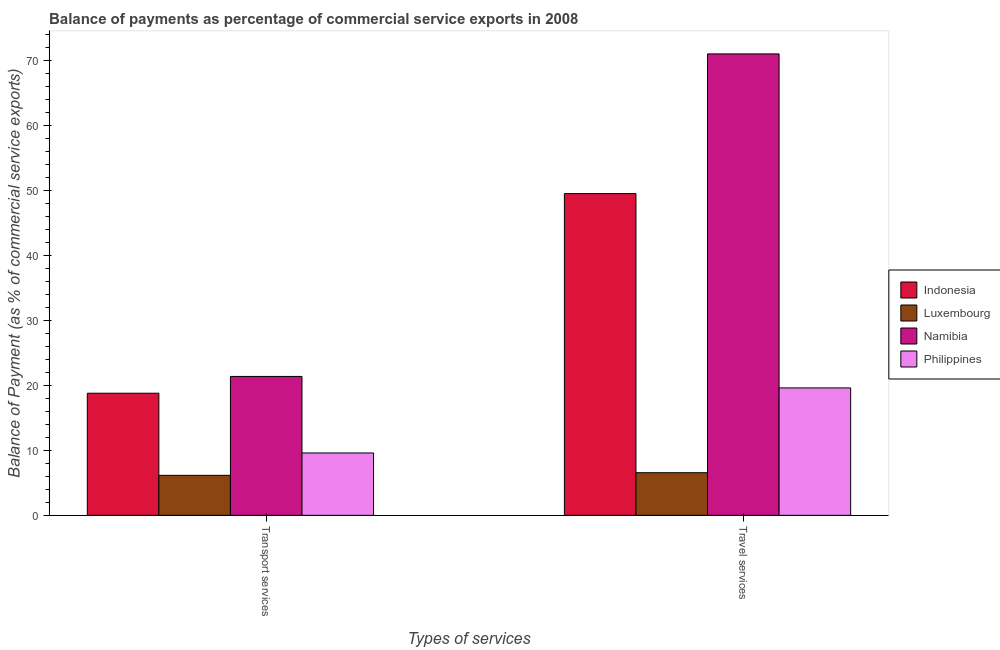How many different coloured bars are there?
Provide a short and direct response. 4. How many groups of bars are there?
Offer a very short reply. 2. Are the number of bars per tick equal to the number of legend labels?
Your response must be concise. Yes. Are the number of bars on each tick of the X-axis equal?
Your answer should be compact. Yes. How many bars are there on the 2nd tick from the right?
Your answer should be very brief. 4. What is the label of the 2nd group of bars from the left?
Provide a short and direct response. Travel services. What is the balance of payments of travel services in Namibia?
Keep it short and to the point. 71.09. Across all countries, what is the maximum balance of payments of transport services?
Offer a terse response. 21.4. Across all countries, what is the minimum balance of payments of travel services?
Offer a terse response. 6.57. In which country was the balance of payments of transport services maximum?
Your response must be concise. Namibia. In which country was the balance of payments of transport services minimum?
Your answer should be very brief. Luxembourg. What is the total balance of payments of travel services in the graph?
Provide a short and direct response. 146.84. What is the difference between the balance of payments of travel services in Philippines and that in Indonesia?
Your answer should be compact. -29.93. What is the difference between the balance of payments of travel services in Namibia and the balance of payments of transport services in Luxembourg?
Ensure brevity in your answer.  64.92. What is the average balance of payments of transport services per country?
Offer a terse response. 14. What is the difference between the balance of payments of travel services and balance of payments of transport services in Luxembourg?
Provide a succinct answer. 0.4. In how many countries, is the balance of payments of travel services greater than 62 %?
Your answer should be very brief. 1. What is the ratio of the balance of payments of travel services in Namibia to that in Philippines?
Your answer should be compact. 3.62. What does the 2nd bar from the left in Transport services represents?
Your answer should be very brief. Luxembourg. How many bars are there?
Your answer should be compact. 8. How many countries are there in the graph?
Your response must be concise. 4. What is the difference between two consecutive major ticks on the Y-axis?
Give a very brief answer. 10. Does the graph contain any zero values?
Provide a short and direct response. No. Does the graph contain grids?
Offer a very short reply. No. Where does the legend appear in the graph?
Offer a terse response. Center right. How many legend labels are there?
Your response must be concise. 4. How are the legend labels stacked?
Keep it short and to the point. Vertical. What is the title of the graph?
Provide a succinct answer. Balance of payments as percentage of commercial service exports in 2008. What is the label or title of the X-axis?
Your answer should be compact. Types of services. What is the label or title of the Y-axis?
Offer a very short reply. Balance of Payment (as % of commercial service exports). What is the Balance of Payment (as % of commercial service exports) in Indonesia in Transport services?
Provide a succinct answer. 18.81. What is the Balance of Payment (as % of commercial service exports) of Luxembourg in Transport services?
Provide a short and direct response. 6.16. What is the Balance of Payment (as % of commercial service exports) of Namibia in Transport services?
Your answer should be very brief. 21.4. What is the Balance of Payment (as % of commercial service exports) of Philippines in Transport services?
Provide a short and direct response. 9.61. What is the Balance of Payment (as % of commercial service exports) of Indonesia in Travel services?
Offer a very short reply. 49.56. What is the Balance of Payment (as % of commercial service exports) in Luxembourg in Travel services?
Provide a succinct answer. 6.57. What is the Balance of Payment (as % of commercial service exports) in Namibia in Travel services?
Your response must be concise. 71.09. What is the Balance of Payment (as % of commercial service exports) of Philippines in Travel services?
Make the answer very short. 19.63. Across all Types of services, what is the maximum Balance of Payment (as % of commercial service exports) of Indonesia?
Offer a terse response. 49.56. Across all Types of services, what is the maximum Balance of Payment (as % of commercial service exports) in Luxembourg?
Keep it short and to the point. 6.57. Across all Types of services, what is the maximum Balance of Payment (as % of commercial service exports) of Namibia?
Offer a very short reply. 71.09. Across all Types of services, what is the maximum Balance of Payment (as % of commercial service exports) in Philippines?
Your response must be concise. 19.63. Across all Types of services, what is the minimum Balance of Payment (as % of commercial service exports) of Indonesia?
Give a very brief answer. 18.81. Across all Types of services, what is the minimum Balance of Payment (as % of commercial service exports) in Luxembourg?
Provide a succinct answer. 6.16. Across all Types of services, what is the minimum Balance of Payment (as % of commercial service exports) in Namibia?
Ensure brevity in your answer.  21.4. Across all Types of services, what is the minimum Balance of Payment (as % of commercial service exports) of Philippines?
Offer a very short reply. 9.61. What is the total Balance of Payment (as % of commercial service exports) in Indonesia in the graph?
Your response must be concise. 68.37. What is the total Balance of Payment (as % of commercial service exports) in Luxembourg in the graph?
Your answer should be very brief. 12.73. What is the total Balance of Payment (as % of commercial service exports) of Namibia in the graph?
Offer a terse response. 92.49. What is the total Balance of Payment (as % of commercial service exports) in Philippines in the graph?
Offer a very short reply. 29.24. What is the difference between the Balance of Payment (as % of commercial service exports) in Indonesia in Transport services and that in Travel services?
Keep it short and to the point. -30.75. What is the difference between the Balance of Payment (as % of commercial service exports) of Luxembourg in Transport services and that in Travel services?
Your response must be concise. -0.4. What is the difference between the Balance of Payment (as % of commercial service exports) in Namibia in Transport services and that in Travel services?
Provide a short and direct response. -49.69. What is the difference between the Balance of Payment (as % of commercial service exports) in Philippines in Transport services and that in Travel services?
Provide a short and direct response. -10.02. What is the difference between the Balance of Payment (as % of commercial service exports) of Indonesia in Transport services and the Balance of Payment (as % of commercial service exports) of Luxembourg in Travel services?
Ensure brevity in your answer.  12.25. What is the difference between the Balance of Payment (as % of commercial service exports) in Indonesia in Transport services and the Balance of Payment (as % of commercial service exports) in Namibia in Travel services?
Your response must be concise. -52.27. What is the difference between the Balance of Payment (as % of commercial service exports) of Indonesia in Transport services and the Balance of Payment (as % of commercial service exports) of Philippines in Travel services?
Keep it short and to the point. -0.82. What is the difference between the Balance of Payment (as % of commercial service exports) of Luxembourg in Transport services and the Balance of Payment (as % of commercial service exports) of Namibia in Travel services?
Keep it short and to the point. -64.92. What is the difference between the Balance of Payment (as % of commercial service exports) of Luxembourg in Transport services and the Balance of Payment (as % of commercial service exports) of Philippines in Travel services?
Your response must be concise. -13.47. What is the difference between the Balance of Payment (as % of commercial service exports) in Namibia in Transport services and the Balance of Payment (as % of commercial service exports) in Philippines in Travel services?
Your answer should be very brief. 1.77. What is the average Balance of Payment (as % of commercial service exports) in Indonesia per Types of services?
Provide a succinct answer. 34.19. What is the average Balance of Payment (as % of commercial service exports) of Luxembourg per Types of services?
Your response must be concise. 6.36. What is the average Balance of Payment (as % of commercial service exports) of Namibia per Types of services?
Your answer should be compact. 46.24. What is the average Balance of Payment (as % of commercial service exports) in Philippines per Types of services?
Offer a terse response. 14.62. What is the difference between the Balance of Payment (as % of commercial service exports) in Indonesia and Balance of Payment (as % of commercial service exports) in Luxembourg in Transport services?
Offer a terse response. 12.65. What is the difference between the Balance of Payment (as % of commercial service exports) of Indonesia and Balance of Payment (as % of commercial service exports) of Namibia in Transport services?
Offer a terse response. -2.59. What is the difference between the Balance of Payment (as % of commercial service exports) in Indonesia and Balance of Payment (as % of commercial service exports) in Philippines in Transport services?
Your answer should be compact. 9.2. What is the difference between the Balance of Payment (as % of commercial service exports) in Luxembourg and Balance of Payment (as % of commercial service exports) in Namibia in Transport services?
Give a very brief answer. -15.24. What is the difference between the Balance of Payment (as % of commercial service exports) in Luxembourg and Balance of Payment (as % of commercial service exports) in Philippines in Transport services?
Keep it short and to the point. -3.45. What is the difference between the Balance of Payment (as % of commercial service exports) of Namibia and Balance of Payment (as % of commercial service exports) of Philippines in Transport services?
Provide a succinct answer. 11.79. What is the difference between the Balance of Payment (as % of commercial service exports) of Indonesia and Balance of Payment (as % of commercial service exports) of Luxembourg in Travel services?
Give a very brief answer. 42.99. What is the difference between the Balance of Payment (as % of commercial service exports) of Indonesia and Balance of Payment (as % of commercial service exports) of Namibia in Travel services?
Provide a short and direct response. -21.52. What is the difference between the Balance of Payment (as % of commercial service exports) in Indonesia and Balance of Payment (as % of commercial service exports) in Philippines in Travel services?
Your answer should be compact. 29.93. What is the difference between the Balance of Payment (as % of commercial service exports) of Luxembourg and Balance of Payment (as % of commercial service exports) of Namibia in Travel services?
Ensure brevity in your answer.  -64.52. What is the difference between the Balance of Payment (as % of commercial service exports) in Luxembourg and Balance of Payment (as % of commercial service exports) in Philippines in Travel services?
Ensure brevity in your answer.  -13.06. What is the difference between the Balance of Payment (as % of commercial service exports) of Namibia and Balance of Payment (as % of commercial service exports) of Philippines in Travel services?
Ensure brevity in your answer.  51.46. What is the ratio of the Balance of Payment (as % of commercial service exports) in Indonesia in Transport services to that in Travel services?
Ensure brevity in your answer.  0.38. What is the ratio of the Balance of Payment (as % of commercial service exports) of Luxembourg in Transport services to that in Travel services?
Ensure brevity in your answer.  0.94. What is the ratio of the Balance of Payment (as % of commercial service exports) in Namibia in Transport services to that in Travel services?
Offer a terse response. 0.3. What is the ratio of the Balance of Payment (as % of commercial service exports) in Philippines in Transport services to that in Travel services?
Provide a short and direct response. 0.49. What is the difference between the highest and the second highest Balance of Payment (as % of commercial service exports) of Indonesia?
Ensure brevity in your answer.  30.75. What is the difference between the highest and the second highest Balance of Payment (as % of commercial service exports) in Luxembourg?
Keep it short and to the point. 0.4. What is the difference between the highest and the second highest Balance of Payment (as % of commercial service exports) in Namibia?
Ensure brevity in your answer.  49.69. What is the difference between the highest and the second highest Balance of Payment (as % of commercial service exports) in Philippines?
Provide a short and direct response. 10.02. What is the difference between the highest and the lowest Balance of Payment (as % of commercial service exports) in Indonesia?
Make the answer very short. 30.75. What is the difference between the highest and the lowest Balance of Payment (as % of commercial service exports) of Luxembourg?
Keep it short and to the point. 0.4. What is the difference between the highest and the lowest Balance of Payment (as % of commercial service exports) of Namibia?
Provide a succinct answer. 49.69. What is the difference between the highest and the lowest Balance of Payment (as % of commercial service exports) of Philippines?
Your response must be concise. 10.02. 